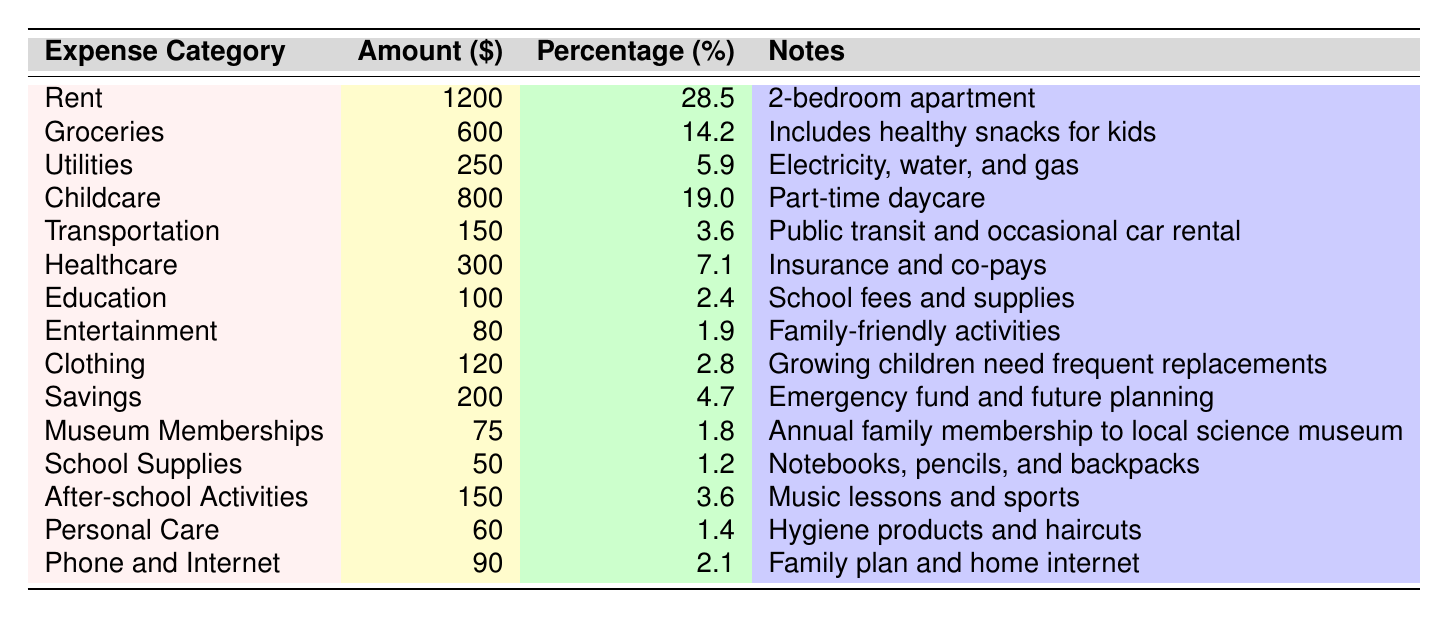What is the largest expense category? The largest expense category listed is Rent, with an amount of $1200. This is directly taken from the "Amount ($)" column for Rent.
Answer: Rent What percentage of total expenses does Groceries represent? Groceries represents 14.2% of total expenses, as indicated in the "Percentage of Total (%)" column next to Groceries.
Answer: 14.2% How much is spent on Childcare and Education combined? The amount spent on Childcare is $800, and on Education, it is $100. Adding these two amounts gives $800 + $100 = $900.
Answer: $900 Is the amount spent on Museum Memberships greater than that spent on School Supplies? The amount for Museum Memberships is $75, and for School Supplies, it is $50. Since $75 is greater than $50, the statement is true.
Answer: Yes What is the total amount spent on Transportation and Healthcare? Transportation costs $150, while Healthcare costs $300. Summing these amounts yields $150 + $300 = $450.
Answer: $450 What is the percentage of total expenses represented by Savings? Savings account for 4.7% of the total expenses, as shown in the "Percentage of Total (%)" column next to Savings.
Answer: 4.7% How much more is spent on Rent compared to Utilities? Rent costs $1200 and Utilities costs $250. The difference is calculated as $1200 - $250 = $950.
Answer: $950 Which expense category has the lowest percentage of total expenses? The expense with the lowest percentage is School Supplies at 1.2%. This is found in the "Percentage of Total (%)" column for School Supplies.
Answer: School Supplies If the total expenses amount to $4200, how much is spent on Entertainment in dollars? The percentage for Entertainment is 1.9%. The dollar amount can be calculated by taking 1.9% of the total expenses: $4200 * (1.9/100) = $79.80, which rounds to $80.
Answer: $80 How much is allocated for After-school Activities? After-school Activities cost $150, as stated in the "Amount ($)" column beside it.
Answer: $150 